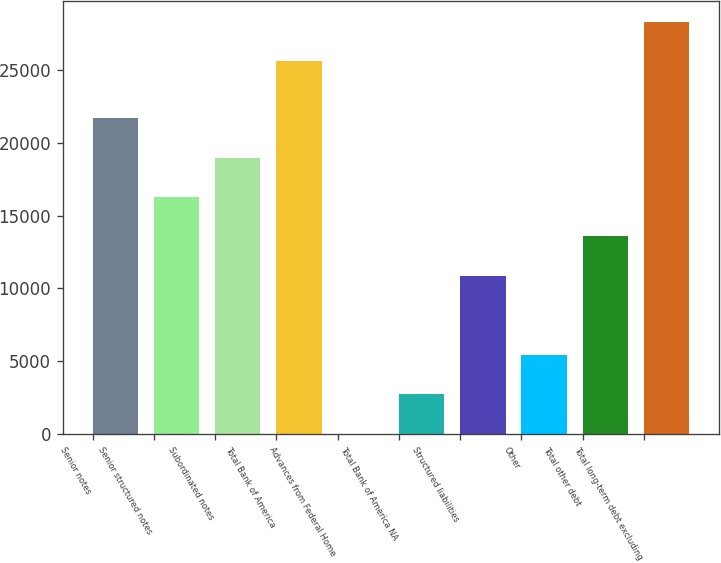Convert chart. <chart><loc_0><loc_0><loc_500><loc_500><bar_chart><fcel>Senior notes<fcel>Senior structured notes<fcel>Subordinated notes<fcel>Total Bank of America<fcel>Advances from Federal Home<fcel>Total Bank of America NA<fcel>Structured liabilities<fcel>Other<fcel>Total other debt<fcel>Total long-term debt excluding<nl><fcel>21707.8<fcel>16283.6<fcel>18995.7<fcel>25612<fcel>11<fcel>2723.1<fcel>10859.4<fcel>5435.2<fcel>13571.5<fcel>28324.1<nl></chart> 